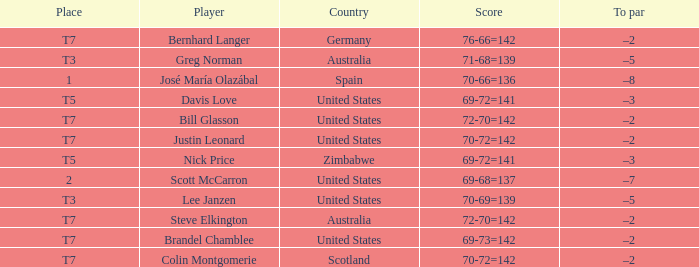Name the Player who has a Place of t7 in Country of united states? Brandel Chamblee, Bill Glasson, Justin Leonard. 